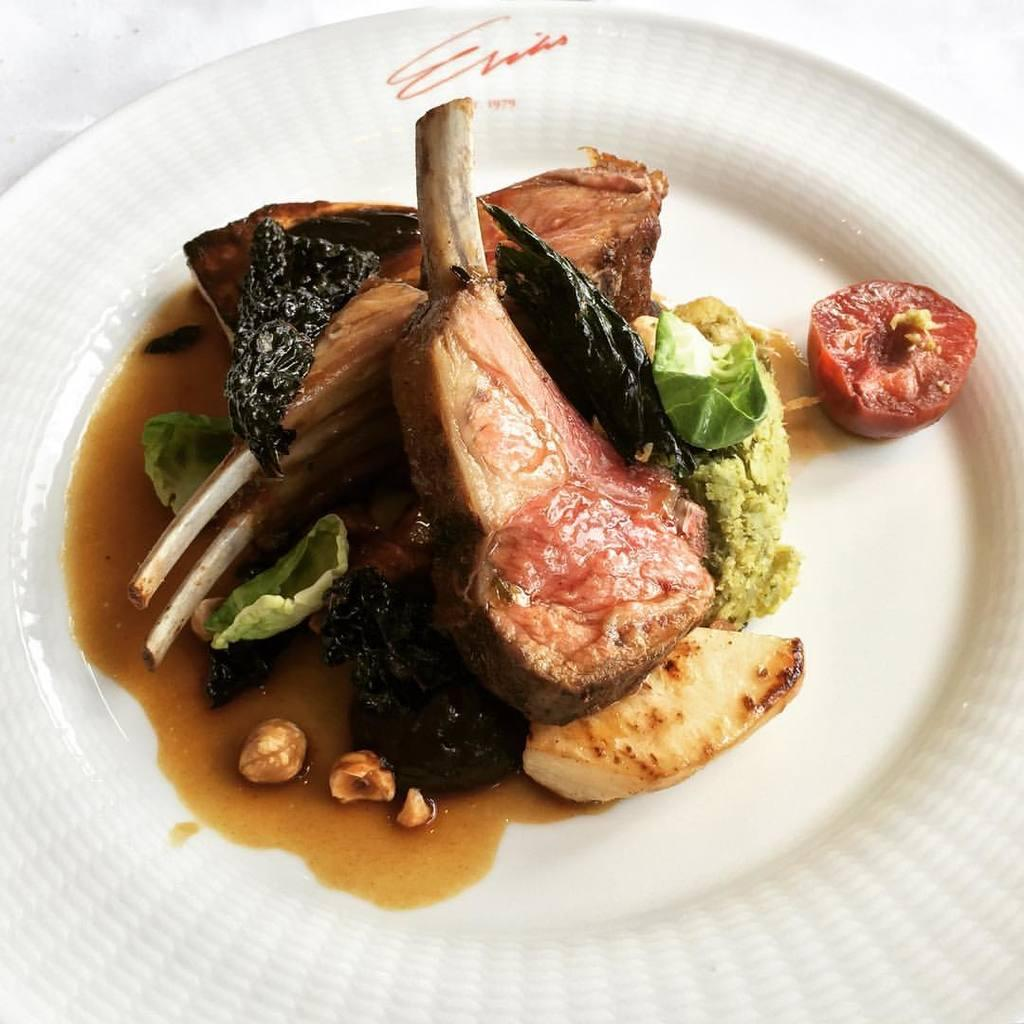What is on the plate that is visible in the image? There are food items arranged on a plate in the image. What color is the plate? The plate is white in color. Where is the plate located in the image? The plate is placed on a surface. What is the color of the background inanimate object in the image? The background of the image is white in color. Can you see a trail of ants leading to the food items on the plate? There is no trail of ants visible in the image. What type of doll is sitting next to the plate? There is no doll present in the image. 